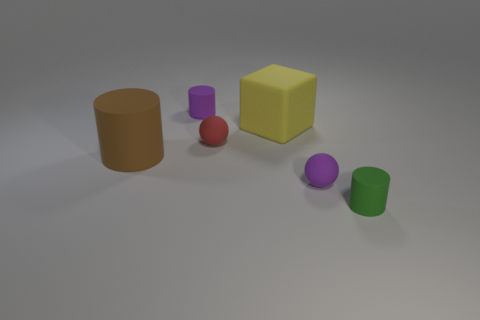Add 4 big purple metal cylinders. How many objects exist? 10 Subtract all spheres. How many objects are left? 4 Subtract all tiny green objects. Subtract all large rubber things. How many objects are left? 3 Add 2 balls. How many balls are left? 4 Add 5 brown rubber cylinders. How many brown rubber cylinders exist? 6 Subtract 0 cyan cubes. How many objects are left? 6 